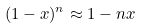<formula> <loc_0><loc_0><loc_500><loc_500>( 1 - x ) ^ { n } \approx { 1 - n x }</formula> 